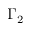<formula> <loc_0><loc_0><loc_500><loc_500>\Gamma _ { 2 }</formula> 